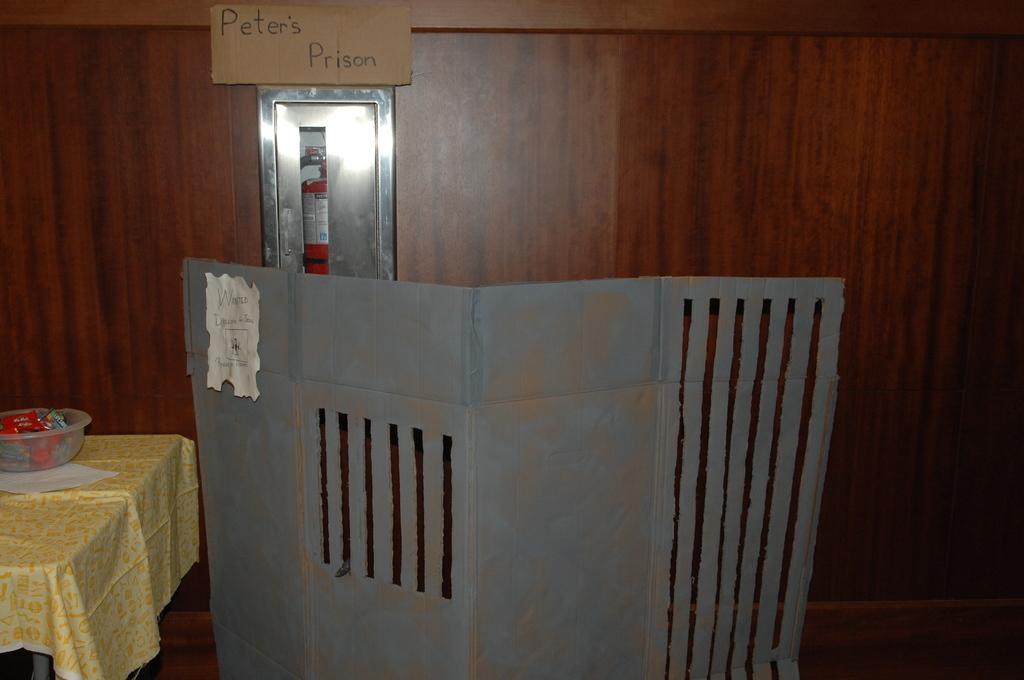What is written on the cardboard sign?
Keep it short and to the point. Peter's prison. What is the picture?
Make the answer very short. Peter's prison. 